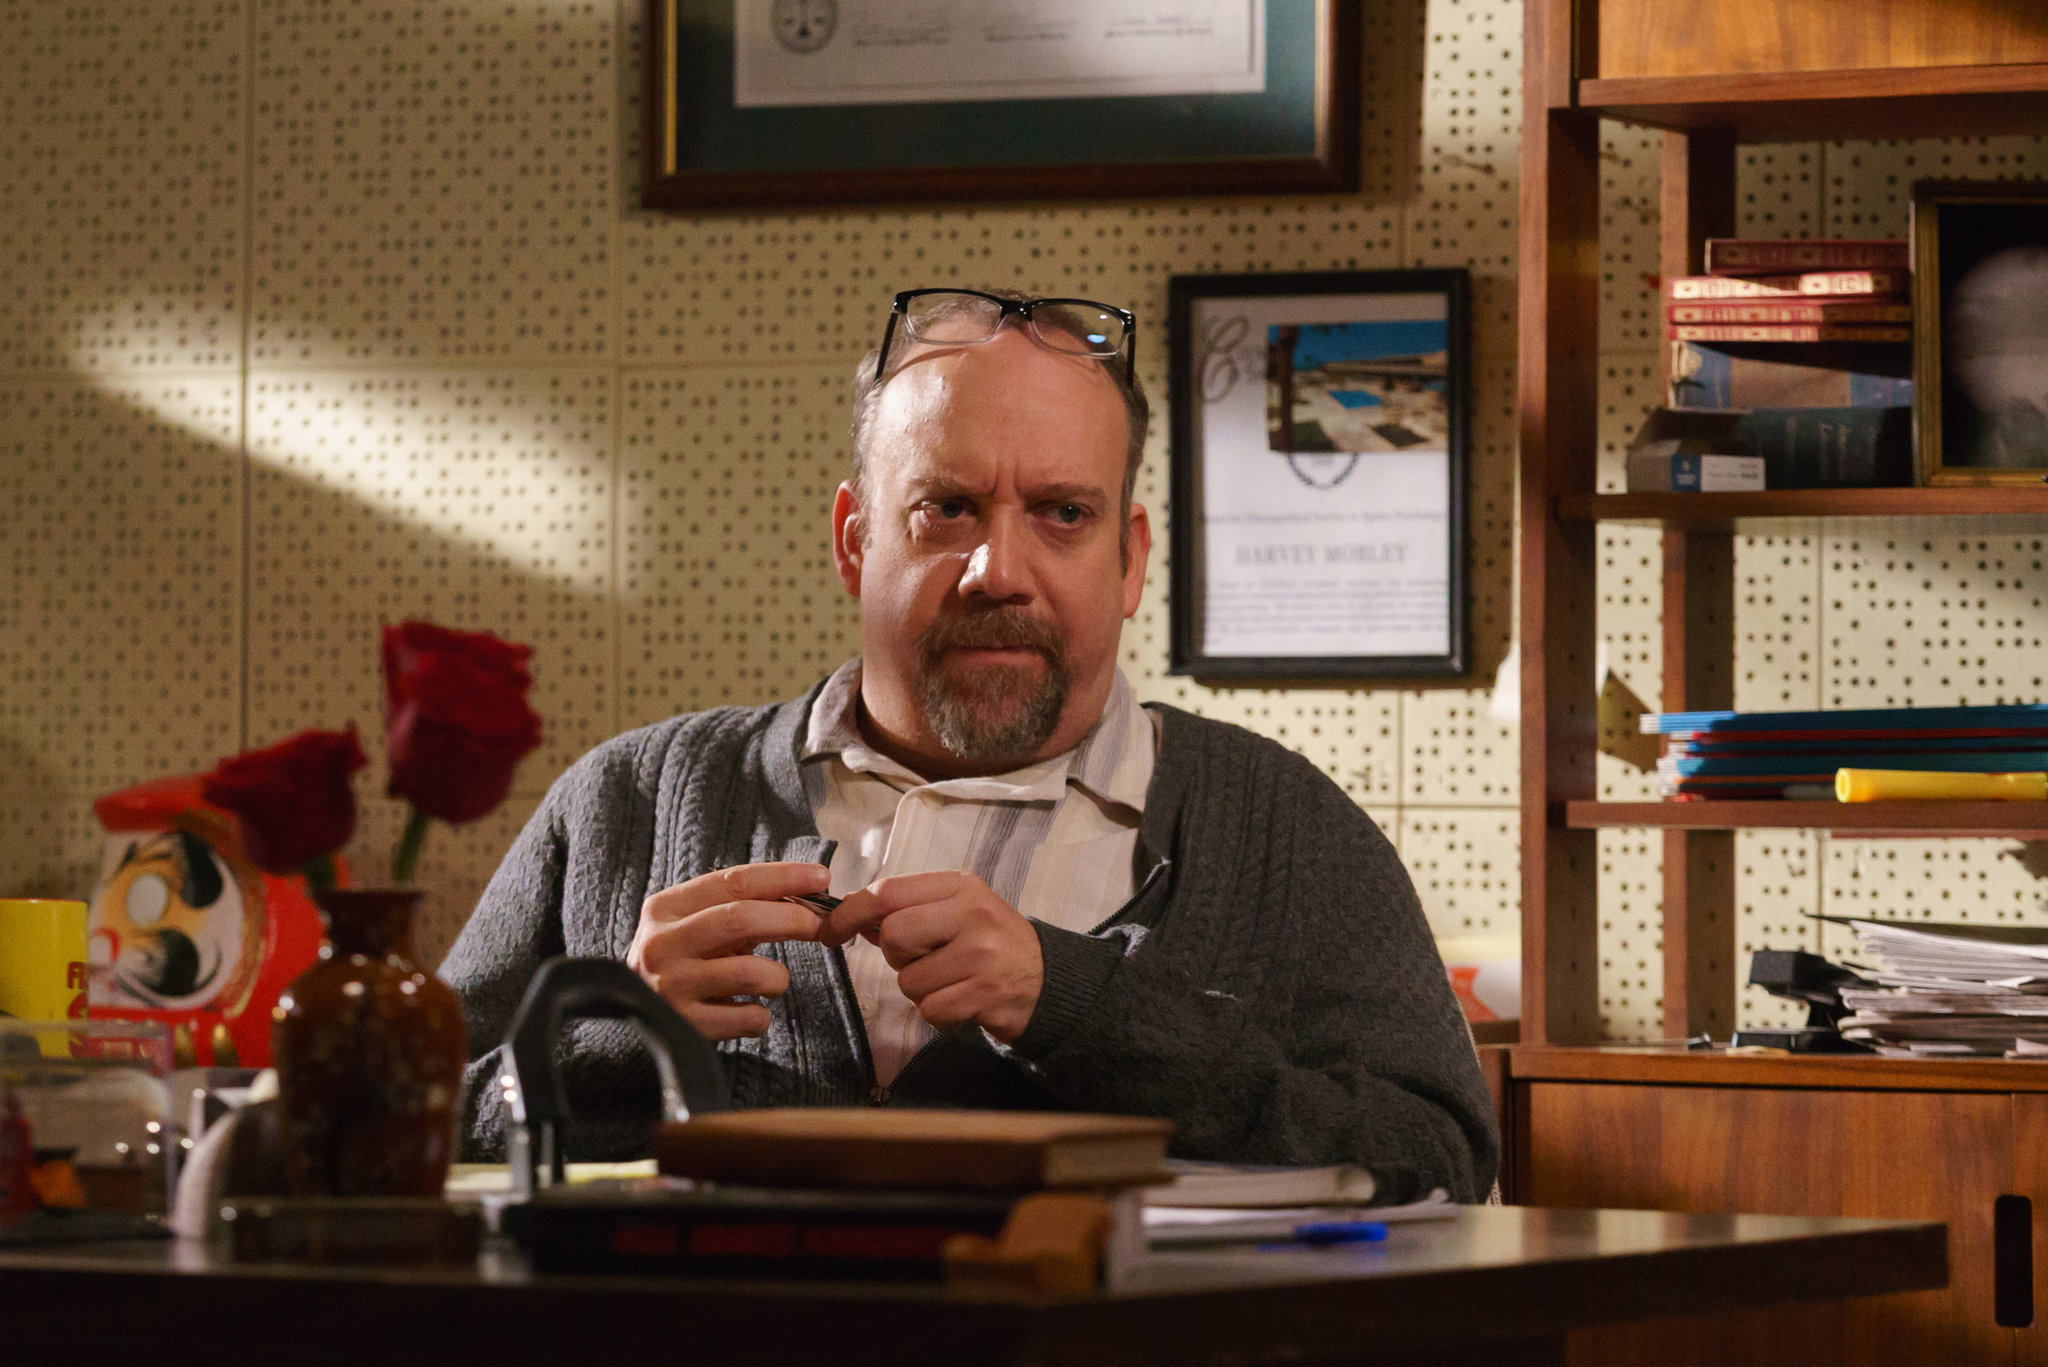What if this scene was set in a different historical period, how would the details change? If this scene were set in a different historical period, say the early 20th century, the details might reflect the aesthetics and technologies of that time. The desk might be wooden with ornate carvings, and instead of modern books, there might be leather-bound volumes. Instead of a coffee mug, there could be a porcelain cup and saucer. The man might be dressed in more formal attire, perhaps in a vest and tie. Technological items would be absent or replaced with vintage equivalents, such as an old-fashioned inkwell instead of a pen, and the lighting would likely come from a gas lamp or an early electric desk lamp, casting a different ambiance over the scene. Imagine if the office suddenly transformed into a magical realm, what might happen next? If the office were to suddenly transform into a magical realm, the walls might glow with mystical runes and the books could levitate, flipping through pages of their own accord. The desk might morph into a grand wooden table adorned with enchanted devices and potions. The man could find himself dressed as a wizard, with the pen becoming a wand, emitting sparks of light. The coffee mug might transform into a goblet of a mysterious potion. The intensity of his concentration could now be attributed to casting a complex spell or deciphering ancient prophecies. The atmosphere would be charged with an aura of magic, with objects and furniture taking on lives of their own, each contributing to the arcane ambiance of the scene. 